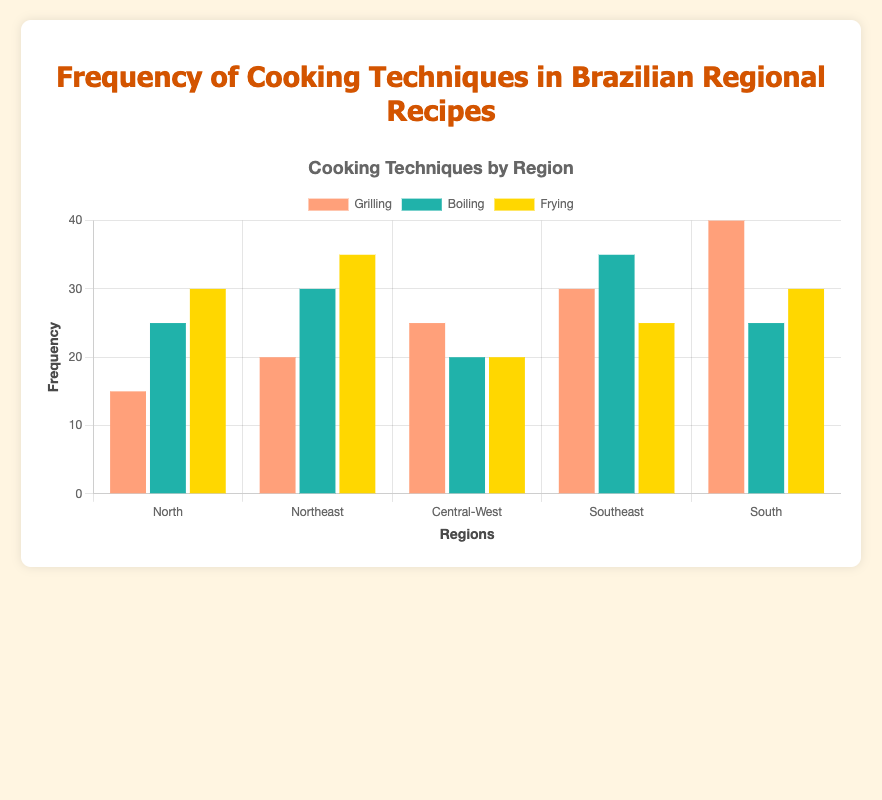What region has the highest frequency of using the grilling technique? Look at the set of bars labeled "Grilling" for each region. The one with the tallest bar represents the highest frequency. The South region has the tallest bar amongst all regions for grilling with a value of 40.
Answer: South What is the total frequency of frying in the South and North regions? Find the values for frying in the South and North regions, which are 30 and 30, respectively. Sum these values: 30 + 30 = 60.
Answer: 60 Which cooking technique is most frequently used in the Southeast region? Identify the tallest bar in the Southeast section. The boiling technique has the highest value at 35.
Answer: Boiling How much more frequently is the grilling technique used in the South compared to the Central-West region? Subtract the frequency of grilling in the Central-West region (25) from the frequency in the South (40): 40 - 25 = 15.
Answer: 15 Which region uses the boiling technique the least? Look at the bars for the boiling technique across all regions and identify the shortest. The Central-West region has the shortest bar with a value of 20.
Answer: Central-West What is the average frequency of the boiling technique across all five regions? Add up all the frequencies for the boiling technique (25 + 30 + 20 + 35 + 25) and divide by the number of regions (5): (25 + 30 + 20 + 35 + 25) / 5 = 27.
Answer: 27 Compare the frequency of frying in the Northeast and Central-West regions. Which is higher, and by how much? Subtract the frequency of frying in the Central-West region (20) from the frequency in the Northeast region (35): 35 - 20 = 15. The Northeast region has a higher frying frequency by 15.
Answer: 15 Is the frequency of grilling in the North region higher or lower than that of boiling in the same region? Compare the bar heights for grilling and boiling in the North region. Grilling has a frequency of 15, which is lower than boiling with a frequency of 25.
Answer: Lower How does the frequency of boiling in the Southeast compare to the North region? Examine the bars for boiling in both the Southeast and North regions. The Southeast has a boiling frequency of 35, while the North has a frequency of 25. 35 is greater than 25.
Answer: The Southeast has a higher frequency What is the combined total frequency of all cooking techniques in the Northeast region? Add the frequency values of grilling (20), boiling (30), and frying (35) for the Northeast: 20 + 30 + 35 = 85.
Answer: 85 